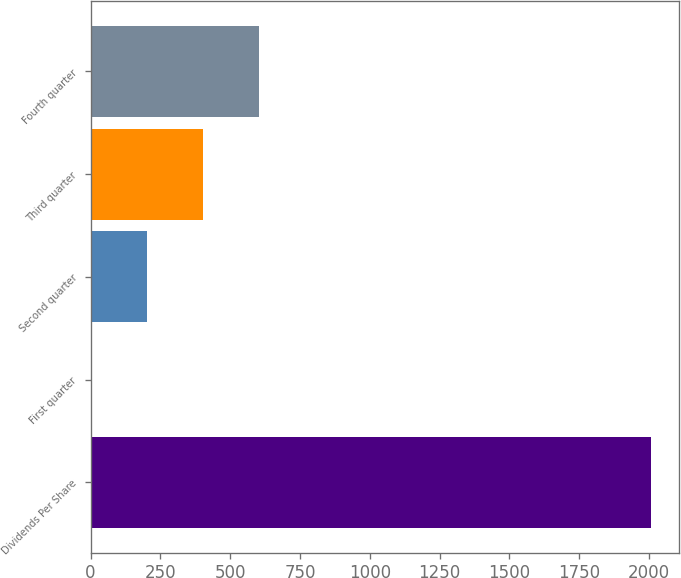Convert chart. <chart><loc_0><loc_0><loc_500><loc_500><bar_chart><fcel>Dividends Per Share<fcel>First quarter<fcel>Second quarter<fcel>Third quarter<fcel>Fourth quarter<nl><fcel>2008<fcel>0.23<fcel>201.01<fcel>401.79<fcel>602.57<nl></chart> 